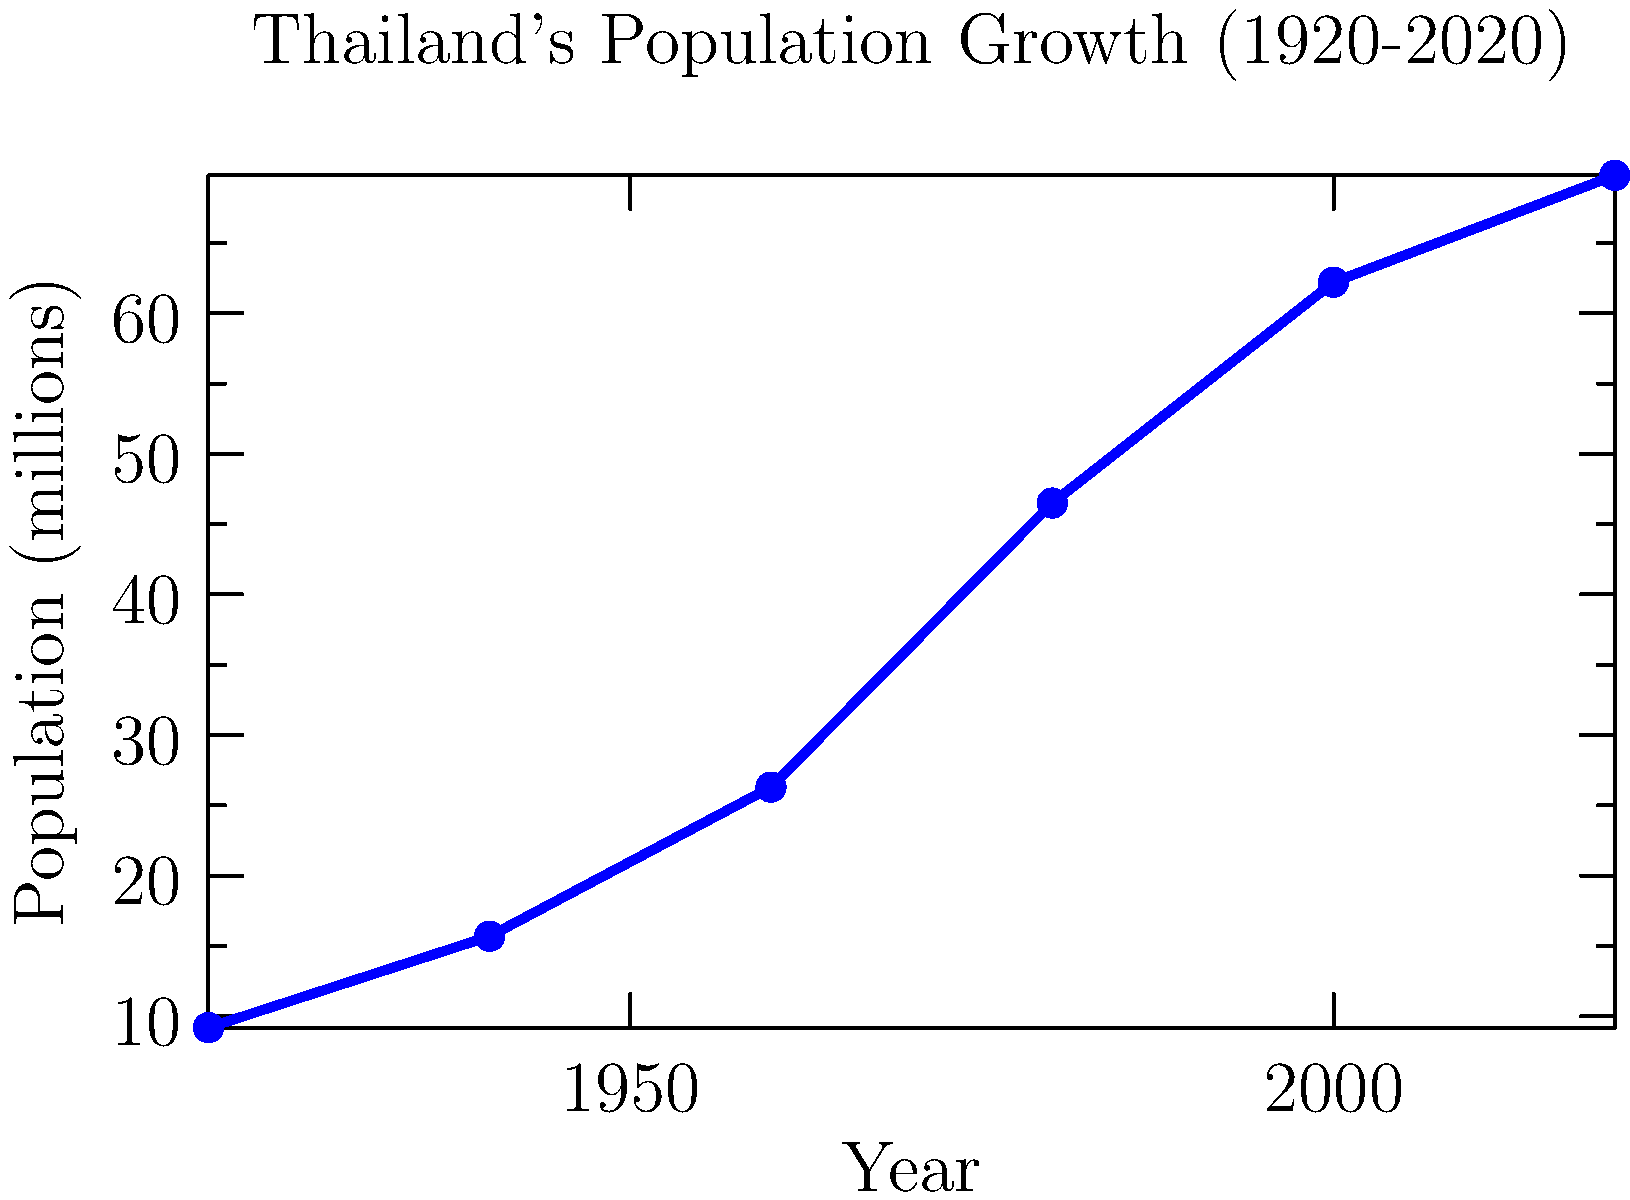Based on the line graph depicting Thailand's population growth from 1920 to 2020, during which 20-year period did the country experience the most rapid increase in population? To determine the period of most rapid population growth, we need to analyze the slope of the line between each pair of consecutive data points. A steeper slope indicates a faster rate of growth.

Step 1: Calculate the population change for each 20-year period:
1920-1940: 15.7 - 9.2 = 6.5 million
1940-1960: 26.3 - 15.7 = 10.6 million
1960-1980: 46.5 - 26.3 = 20.2 million
1980-2000: 62.2 - 46.5 = 15.7 million
2000-2020: 69.8 - 62.2 = 7.6 million

Step 2: Identify the largest change:
The largest change occurred between 1960 and 1980, with an increase of 20.2 million people.

Step 3: Confirm visually:
The steepest slope on the graph is indeed between 1960 and 1980, supporting our calculation.

Therefore, the period of most rapid population growth in Thailand was from 1960 to 1980.
Answer: 1960-1980 